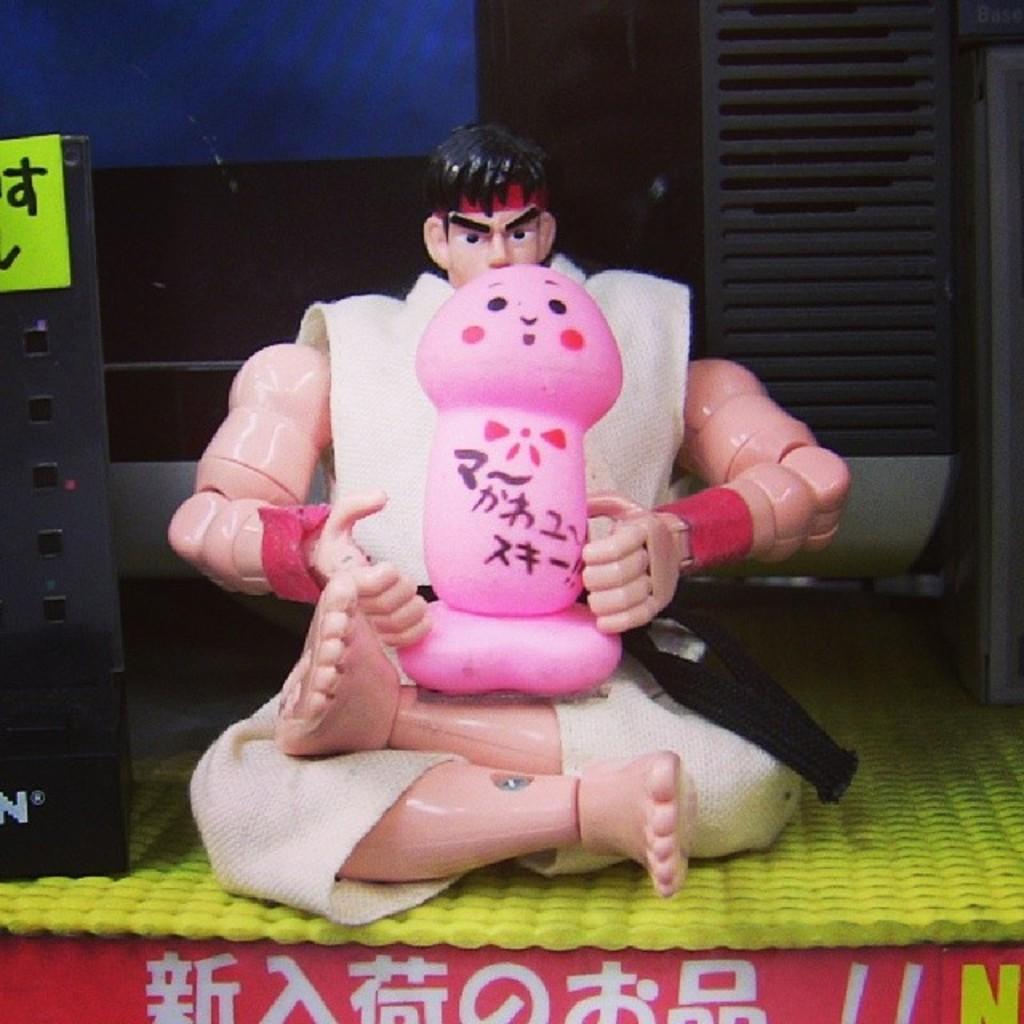How would you summarize this image in a sentence or two? Here I can see a toy of a person is placed on a yellow color surface. On the left side there is a metal object. In the background there are some objects in the dark. At the bottom there is red color board on which I can see some text. 